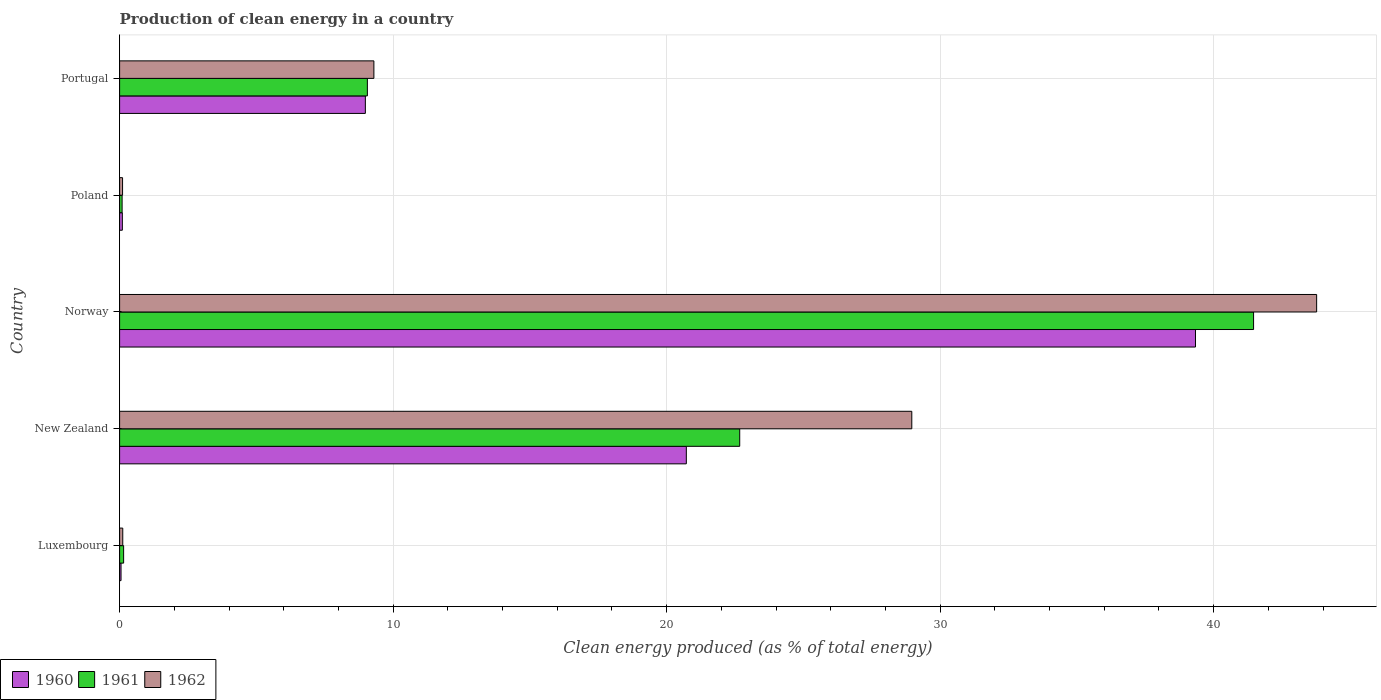Are the number of bars on each tick of the Y-axis equal?
Ensure brevity in your answer.  Yes. In how many cases, is the number of bars for a given country not equal to the number of legend labels?
Provide a short and direct response. 0. What is the percentage of clean energy produced in 1962 in Luxembourg?
Your response must be concise. 0.12. Across all countries, what is the maximum percentage of clean energy produced in 1960?
Keep it short and to the point. 39.34. Across all countries, what is the minimum percentage of clean energy produced in 1960?
Your answer should be very brief. 0.05. In which country was the percentage of clean energy produced in 1962 minimum?
Your answer should be compact. Poland. What is the total percentage of clean energy produced in 1962 in the graph?
Offer a very short reply. 82.25. What is the difference between the percentage of clean energy produced in 1960 in New Zealand and that in Norway?
Provide a succinct answer. -18.62. What is the difference between the percentage of clean energy produced in 1962 in Luxembourg and the percentage of clean energy produced in 1960 in Norway?
Offer a very short reply. -39.22. What is the average percentage of clean energy produced in 1960 per country?
Provide a succinct answer. 13.84. What is the difference between the percentage of clean energy produced in 1961 and percentage of clean energy produced in 1960 in New Zealand?
Offer a terse response. 1.95. What is the ratio of the percentage of clean energy produced in 1962 in Luxembourg to that in Poland?
Make the answer very short. 1.07. Is the percentage of clean energy produced in 1960 in Norway less than that in Poland?
Offer a very short reply. No. Is the difference between the percentage of clean energy produced in 1961 in New Zealand and Poland greater than the difference between the percentage of clean energy produced in 1960 in New Zealand and Poland?
Provide a succinct answer. Yes. What is the difference between the highest and the second highest percentage of clean energy produced in 1962?
Keep it short and to the point. 14.8. What is the difference between the highest and the lowest percentage of clean energy produced in 1962?
Make the answer very short. 43.66. In how many countries, is the percentage of clean energy produced in 1960 greater than the average percentage of clean energy produced in 1960 taken over all countries?
Provide a succinct answer. 2. Is the sum of the percentage of clean energy produced in 1961 in Luxembourg and Poland greater than the maximum percentage of clean energy produced in 1960 across all countries?
Your response must be concise. No. What does the 3rd bar from the top in Norway represents?
Offer a terse response. 1960. Is it the case that in every country, the sum of the percentage of clean energy produced in 1961 and percentage of clean energy produced in 1962 is greater than the percentage of clean energy produced in 1960?
Keep it short and to the point. Yes. How many bars are there?
Your answer should be compact. 15. How many countries are there in the graph?
Provide a succinct answer. 5. Are the values on the major ticks of X-axis written in scientific E-notation?
Provide a short and direct response. No. Where does the legend appear in the graph?
Your answer should be very brief. Bottom left. How many legend labels are there?
Your answer should be compact. 3. What is the title of the graph?
Your response must be concise. Production of clean energy in a country. What is the label or title of the X-axis?
Provide a succinct answer. Clean energy produced (as % of total energy). What is the Clean energy produced (as % of total energy) of 1960 in Luxembourg?
Provide a short and direct response. 0.05. What is the Clean energy produced (as % of total energy) of 1961 in Luxembourg?
Make the answer very short. 0.15. What is the Clean energy produced (as % of total energy) in 1962 in Luxembourg?
Your response must be concise. 0.12. What is the Clean energy produced (as % of total energy) of 1960 in New Zealand?
Your answer should be compact. 20.72. What is the Clean energy produced (as % of total energy) in 1961 in New Zealand?
Provide a short and direct response. 22.67. What is the Clean energy produced (as % of total energy) in 1962 in New Zealand?
Give a very brief answer. 28.96. What is the Clean energy produced (as % of total energy) in 1960 in Norway?
Provide a succinct answer. 39.34. What is the Clean energy produced (as % of total energy) in 1961 in Norway?
Offer a very short reply. 41.46. What is the Clean energy produced (as % of total energy) of 1962 in Norway?
Provide a succinct answer. 43.77. What is the Clean energy produced (as % of total energy) of 1960 in Poland?
Give a very brief answer. 0.1. What is the Clean energy produced (as % of total energy) in 1961 in Poland?
Give a very brief answer. 0.09. What is the Clean energy produced (as % of total energy) in 1962 in Poland?
Give a very brief answer. 0.11. What is the Clean energy produced (as % of total energy) in 1960 in Portugal?
Offer a terse response. 8.99. What is the Clean energy produced (as % of total energy) in 1961 in Portugal?
Ensure brevity in your answer.  9.06. What is the Clean energy produced (as % of total energy) in 1962 in Portugal?
Provide a short and direct response. 9.3. Across all countries, what is the maximum Clean energy produced (as % of total energy) in 1960?
Make the answer very short. 39.34. Across all countries, what is the maximum Clean energy produced (as % of total energy) of 1961?
Make the answer very short. 41.46. Across all countries, what is the maximum Clean energy produced (as % of total energy) of 1962?
Your response must be concise. 43.77. Across all countries, what is the minimum Clean energy produced (as % of total energy) in 1960?
Offer a very short reply. 0.05. Across all countries, what is the minimum Clean energy produced (as % of total energy) in 1961?
Give a very brief answer. 0.09. Across all countries, what is the minimum Clean energy produced (as % of total energy) of 1962?
Offer a terse response. 0.11. What is the total Clean energy produced (as % of total energy) in 1960 in the graph?
Make the answer very short. 69.19. What is the total Clean energy produced (as % of total energy) of 1961 in the graph?
Your answer should be very brief. 73.43. What is the total Clean energy produced (as % of total energy) in 1962 in the graph?
Provide a succinct answer. 82.25. What is the difference between the Clean energy produced (as % of total energy) in 1960 in Luxembourg and that in New Zealand?
Your answer should be compact. -20.67. What is the difference between the Clean energy produced (as % of total energy) of 1961 in Luxembourg and that in New Zealand?
Provide a succinct answer. -22.53. What is the difference between the Clean energy produced (as % of total energy) of 1962 in Luxembourg and that in New Zealand?
Offer a very short reply. -28.85. What is the difference between the Clean energy produced (as % of total energy) of 1960 in Luxembourg and that in Norway?
Your answer should be very brief. -39.28. What is the difference between the Clean energy produced (as % of total energy) of 1961 in Luxembourg and that in Norway?
Your answer should be compact. -41.31. What is the difference between the Clean energy produced (as % of total energy) in 1962 in Luxembourg and that in Norway?
Your answer should be very brief. -43.65. What is the difference between the Clean energy produced (as % of total energy) in 1960 in Luxembourg and that in Poland?
Ensure brevity in your answer.  -0.05. What is the difference between the Clean energy produced (as % of total energy) in 1961 in Luxembourg and that in Poland?
Give a very brief answer. 0.06. What is the difference between the Clean energy produced (as % of total energy) in 1962 in Luxembourg and that in Poland?
Your answer should be compact. 0.01. What is the difference between the Clean energy produced (as % of total energy) of 1960 in Luxembourg and that in Portugal?
Your answer should be compact. -8.93. What is the difference between the Clean energy produced (as % of total energy) of 1961 in Luxembourg and that in Portugal?
Provide a short and direct response. -8.91. What is the difference between the Clean energy produced (as % of total energy) in 1962 in Luxembourg and that in Portugal?
Provide a short and direct response. -9.18. What is the difference between the Clean energy produced (as % of total energy) of 1960 in New Zealand and that in Norway?
Your answer should be very brief. -18.62. What is the difference between the Clean energy produced (as % of total energy) of 1961 in New Zealand and that in Norway?
Offer a very short reply. -18.79. What is the difference between the Clean energy produced (as % of total energy) in 1962 in New Zealand and that in Norway?
Your response must be concise. -14.8. What is the difference between the Clean energy produced (as % of total energy) in 1960 in New Zealand and that in Poland?
Provide a short and direct response. 20.62. What is the difference between the Clean energy produced (as % of total energy) in 1961 in New Zealand and that in Poland?
Give a very brief answer. 22.58. What is the difference between the Clean energy produced (as % of total energy) of 1962 in New Zealand and that in Poland?
Make the answer very short. 28.86. What is the difference between the Clean energy produced (as % of total energy) in 1960 in New Zealand and that in Portugal?
Keep it short and to the point. 11.74. What is the difference between the Clean energy produced (as % of total energy) in 1961 in New Zealand and that in Portugal?
Provide a short and direct response. 13.61. What is the difference between the Clean energy produced (as % of total energy) in 1962 in New Zealand and that in Portugal?
Your answer should be compact. 19.67. What is the difference between the Clean energy produced (as % of total energy) of 1960 in Norway and that in Poland?
Offer a terse response. 39.24. What is the difference between the Clean energy produced (as % of total energy) of 1961 in Norway and that in Poland?
Offer a very short reply. 41.37. What is the difference between the Clean energy produced (as % of total energy) of 1962 in Norway and that in Poland?
Your answer should be very brief. 43.66. What is the difference between the Clean energy produced (as % of total energy) of 1960 in Norway and that in Portugal?
Provide a succinct answer. 30.35. What is the difference between the Clean energy produced (as % of total energy) of 1961 in Norway and that in Portugal?
Provide a short and direct response. 32.4. What is the difference between the Clean energy produced (as % of total energy) in 1962 in Norway and that in Portugal?
Keep it short and to the point. 34.47. What is the difference between the Clean energy produced (as % of total energy) in 1960 in Poland and that in Portugal?
Give a very brief answer. -8.88. What is the difference between the Clean energy produced (as % of total energy) in 1961 in Poland and that in Portugal?
Make the answer very short. -8.97. What is the difference between the Clean energy produced (as % of total energy) of 1962 in Poland and that in Portugal?
Your answer should be compact. -9.19. What is the difference between the Clean energy produced (as % of total energy) in 1960 in Luxembourg and the Clean energy produced (as % of total energy) in 1961 in New Zealand?
Provide a short and direct response. -22.62. What is the difference between the Clean energy produced (as % of total energy) of 1960 in Luxembourg and the Clean energy produced (as % of total energy) of 1962 in New Zealand?
Make the answer very short. -28.91. What is the difference between the Clean energy produced (as % of total energy) of 1961 in Luxembourg and the Clean energy produced (as % of total energy) of 1962 in New Zealand?
Give a very brief answer. -28.82. What is the difference between the Clean energy produced (as % of total energy) of 1960 in Luxembourg and the Clean energy produced (as % of total energy) of 1961 in Norway?
Your answer should be very brief. -41.41. What is the difference between the Clean energy produced (as % of total energy) in 1960 in Luxembourg and the Clean energy produced (as % of total energy) in 1962 in Norway?
Your response must be concise. -43.71. What is the difference between the Clean energy produced (as % of total energy) of 1961 in Luxembourg and the Clean energy produced (as % of total energy) of 1962 in Norway?
Keep it short and to the point. -43.62. What is the difference between the Clean energy produced (as % of total energy) in 1960 in Luxembourg and the Clean energy produced (as % of total energy) in 1961 in Poland?
Ensure brevity in your answer.  -0.04. What is the difference between the Clean energy produced (as % of total energy) in 1960 in Luxembourg and the Clean energy produced (as % of total energy) in 1962 in Poland?
Ensure brevity in your answer.  -0.06. What is the difference between the Clean energy produced (as % of total energy) in 1961 in Luxembourg and the Clean energy produced (as % of total energy) in 1962 in Poland?
Keep it short and to the point. 0.04. What is the difference between the Clean energy produced (as % of total energy) in 1960 in Luxembourg and the Clean energy produced (as % of total energy) in 1961 in Portugal?
Give a very brief answer. -9.01. What is the difference between the Clean energy produced (as % of total energy) of 1960 in Luxembourg and the Clean energy produced (as % of total energy) of 1962 in Portugal?
Offer a very short reply. -9.24. What is the difference between the Clean energy produced (as % of total energy) in 1961 in Luxembourg and the Clean energy produced (as % of total energy) in 1962 in Portugal?
Your answer should be compact. -9.15. What is the difference between the Clean energy produced (as % of total energy) in 1960 in New Zealand and the Clean energy produced (as % of total energy) in 1961 in Norway?
Give a very brief answer. -20.74. What is the difference between the Clean energy produced (as % of total energy) in 1960 in New Zealand and the Clean energy produced (as % of total energy) in 1962 in Norway?
Keep it short and to the point. -23.05. What is the difference between the Clean energy produced (as % of total energy) in 1961 in New Zealand and the Clean energy produced (as % of total energy) in 1962 in Norway?
Ensure brevity in your answer.  -21.09. What is the difference between the Clean energy produced (as % of total energy) in 1960 in New Zealand and the Clean energy produced (as % of total energy) in 1961 in Poland?
Keep it short and to the point. 20.63. What is the difference between the Clean energy produced (as % of total energy) in 1960 in New Zealand and the Clean energy produced (as % of total energy) in 1962 in Poland?
Give a very brief answer. 20.61. What is the difference between the Clean energy produced (as % of total energy) in 1961 in New Zealand and the Clean energy produced (as % of total energy) in 1962 in Poland?
Offer a terse response. 22.56. What is the difference between the Clean energy produced (as % of total energy) in 1960 in New Zealand and the Clean energy produced (as % of total energy) in 1961 in Portugal?
Provide a succinct answer. 11.66. What is the difference between the Clean energy produced (as % of total energy) in 1960 in New Zealand and the Clean energy produced (as % of total energy) in 1962 in Portugal?
Your answer should be compact. 11.42. What is the difference between the Clean energy produced (as % of total energy) in 1961 in New Zealand and the Clean energy produced (as % of total energy) in 1962 in Portugal?
Ensure brevity in your answer.  13.38. What is the difference between the Clean energy produced (as % of total energy) in 1960 in Norway and the Clean energy produced (as % of total energy) in 1961 in Poland?
Provide a succinct answer. 39.24. What is the difference between the Clean energy produced (as % of total energy) of 1960 in Norway and the Clean energy produced (as % of total energy) of 1962 in Poland?
Offer a very short reply. 39.23. What is the difference between the Clean energy produced (as % of total energy) in 1961 in Norway and the Clean energy produced (as % of total energy) in 1962 in Poland?
Keep it short and to the point. 41.35. What is the difference between the Clean energy produced (as % of total energy) of 1960 in Norway and the Clean energy produced (as % of total energy) of 1961 in Portugal?
Offer a terse response. 30.28. What is the difference between the Clean energy produced (as % of total energy) of 1960 in Norway and the Clean energy produced (as % of total energy) of 1962 in Portugal?
Your answer should be very brief. 30.04. What is the difference between the Clean energy produced (as % of total energy) of 1961 in Norway and the Clean energy produced (as % of total energy) of 1962 in Portugal?
Offer a very short reply. 32.16. What is the difference between the Clean energy produced (as % of total energy) of 1960 in Poland and the Clean energy produced (as % of total energy) of 1961 in Portugal?
Your response must be concise. -8.96. What is the difference between the Clean energy produced (as % of total energy) in 1960 in Poland and the Clean energy produced (as % of total energy) in 1962 in Portugal?
Give a very brief answer. -9.2. What is the difference between the Clean energy produced (as % of total energy) of 1961 in Poland and the Clean energy produced (as % of total energy) of 1962 in Portugal?
Give a very brief answer. -9.21. What is the average Clean energy produced (as % of total energy) in 1960 per country?
Your response must be concise. 13.84. What is the average Clean energy produced (as % of total energy) in 1961 per country?
Offer a terse response. 14.69. What is the average Clean energy produced (as % of total energy) in 1962 per country?
Your answer should be very brief. 16.45. What is the difference between the Clean energy produced (as % of total energy) in 1960 and Clean energy produced (as % of total energy) in 1961 in Luxembourg?
Provide a short and direct response. -0.09. What is the difference between the Clean energy produced (as % of total energy) in 1960 and Clean energy produced (as % of total energy) in 1962 in Luxembourg?
Make the answer very short. -0.06. What is the difference between the Clean energy produced (as % of total energy) in 1961 and Clean energy produced (as % of total energy) in 1962 in Luxembourg?
Your response must be concise. 0.03. What is the difference between the Clean energy produced (as % of total energy) in 1960 and Clean energy produced (as % of total energy) in 1961 in New Zealand?
Your answer should be compact. -1.95. What is the difference between the Clean energy produced (as % of total energy) in 1960 and Clean energy produced (as % of total energy) in 1962 in New Zealand?
Your answer should be very brief. -8.24. What is the difference between the Clean energy produced (as % of total energy) in 1961 and Clean energy produced (as % of total energy) in 1962 in New Zealand?
Ensure brevity in your answer.  -6.29. What is the difference between the Clean energy produced (as % of total energy) in 1960 and Clean energy produced (as % of total energy) in 1961 in Norway?
Provide a short and direct response. -2.12. What is the difference between the Clean energy produced (as % of total energy) of 1960 and Clean energy produced (as % of total energy) of 1962 in Norway?
Offer a very short reply. -4.43. What is the difference between the Clean energy produced (as % of total energy) in 1961 and Clean energy produced (as % of total energy) in 1962 in Norway?
Give a very brief answer. -2.31. What is the difference between the Clean energy produced (as % of total energy) in 1960 and Clean energy produced (as % of total energy) in 1961 in Poland?
Your answer should be compact. 0.01. What is the difference between the Clean energy produced (as % of total energy) of 1960 and Clean energy produced (as % of total energy) of 1962 in Poland?
Offer a very short reply. -0.01. What is the difference between the Clean energy produced (as % of total energy) of 1961 and Clean energy produced (as % of total energy) of 1962 in Poland?
Your response must be concise. -0.02. What is the difference between the Clean energy produced (as % of total energy) in 1960 and Clean energy produced (as % of total energy) in 1961 in Portugal?
Your response must be concise. -0.07. What is the difference between the Clean energy produced (as % of total energy) in 1960 and Clean energy produced (as % of total energy) in 1962 in Portugal?
Your response must be concise. -0.31. What is the difference between the Clean energy produced (as % of total energy) in 1961 and Clean energy produced (as % of total energy) in 1962 in Portugal?
Keep it short and to the point. -0.24. What is the ratio of the Clean energy produced (as % of total energy) in 1960 in Luxembourg to that in New Zealand?
Your answer should be compact. 0. What is the ratio of the Clean energy produced (as % of total energy) in 1961 in Luxembourg to that in New Zealand?
Ensure brevity in your answer.  0.01. What is the ratio of the Clean energy produced (as % of total energy) in 1962 in Luxembourg to that in New Zealand?
Offer a very short reply. 0. What is the ratio of the Clean energy produced (as % of total energy) of 1960 in Luxembourg to that in Norway?
Your answer should be compact. 0. What is the ratio of the Clean energy produced (as % of total energy) in 1961 in Luxembourg to that in Norway?
Your answer should be compact. 0. What is the ratio of the Clean energy produced (as % of total energy) in 1962 in Luxembourg to that in Norway?
Offer a terse response. 0. What is the ratio of the Clean energy produced (as % of total energy) in 1960 in Luxembourg to that in Poland?
Ensure brevity in your answer.  0.52. What is the ratio of the Clean energy produced (as % of total energy) in 1961 in Luxembourg to that in Poland?
Provide a short and direct response. 1.6. What is the ratio of the Clean energy produced (as % of total energy) of 1962 in Luxembourg to that in Poland?
Provide a short and direct response. 1.07. What is the ratio of the Clean energy produced (as % of total energy) of 1960 in Luxembourg to that in Portugal?
Make the answer very short. 0.01. What is the ratio of the Clean energy produced (as % of total energy) in 1961 in Luxembourg to that in Portugal?
Provide a succinct answer. 0.02. What is the ratio of the Clean energy produced (as % of total energy) in 1962 in Luxembourg to that in Portugal?
Keep it short and to the point. 0.01. What is the ratio of the Clean energy produced (as % of total energy) in 1960 in New Zealand to that in Norway?
Your response must be concise. 0.53. What is the ratio of the Clean energy produced (as % of total energy) of 1961 in New Zealand to that in Norway?
Make the answer very short. 0.55. What is the ratio of the Clean energy produced (as % of total energy) of 1962 in New Zealand to that in Norway?
Your response must be concise. 0.66. What is the ratio of the Clean energy produced (as % of total energy) of 1960 in New Zealand to that in Poland?
Give a very brief answer. 206.53. What is the ratio of the Clean energy produced (as % of total energy) of 1961 in New Zealand to that in Poland?
Your response must be concise. 247.72. What is the ratio of the Clean energy produced (as % of total energy) in 1962 in New Zealand to that in Poland?
Provide a short and direct response. 267.62. What is the ratio of the Clean energy produced (as % of total energy) in 1960 in New Zealand to that in Portugal?
Make the answer very short. 2.31. What is the ratio of the Clean energy produced (as % of total energy) in 1961 in New Zealand to that in Portugal?
Provide a short and direct response. 2.5. What is the ratio of the Clean energy produced (as % of total energy) in 1962 in New Zealand to that in Portugal?
Your response must be concise. 3.12. What is the ratio of the Clean energy produced (as % of total energy) in 1960 in Norway to that in Poland?
Provide a short and direct response. 392.08. What is the ratio of the Clean energy produced (as % of total energy) of 1961 in Norway to that in Poland?
Provide a short and direct response. 452.99. What is the ratio of the Clean energy produced (as % of total energy) of 1962 in Norway to that in Poland?
Offer a terse response. 404.39. What is the ratio of the Clean energy produced (as % of total energy) in 1960 in Norway to that in Portugal?
Your answer should be compact. 4.38. What is the ratio of the Clean energy produced (as % of total energy) in 1961 in Norway to that in Portugal?
Ensure brevity in your answer.  4.58. What is the ratio of the Clean energy produced (as % of total energy) of 1962 in Norway to that in Portugal?
Ensure brevity in your answer.  4.71. What is the ratio of the Clean energy produced (as % of total energy) in 1960 in Poland to that in Portugal?
Provide a short and direct response. 0.01. What is the ratio of the Clean energy produced (as % of total energy) of 1961 in Poland to that in Portugal?
Ensure brevity in your answer.  0.01. What is the ratio of the Clean energy produced (as % of total energy) of 1962 in Poland to that in Portugal?
Your response must be concise. 0.01. What is the difference between the highest and the second highest Clean energy produced (as % of total energy) of 1960?
Your answer should be very brief. 18.62. What is the difference between the highest and the second highest Clean energy produced (as % of total energy) in 1961?
Give a very brief answer. 18.79. What is the difference between the highest and the second highest Clean energy produced (as % of total energy) of 1962?
Your answer should be very brief. 14.8. What is the difference between the highest and the lowest Clean energy produced (as % of total energy) of 1960?
Your answer should be very brief. 39.28. What is the difference between the highest and the lowest Clean energy produced (as % of total energy) in 1961?
Ensure brevity in your answer.  41.37. What is the difference between the highest and the lowest Clean energy produced (as % of total energy) in 1962?
Ensure brevity in your answer.  43.66. 